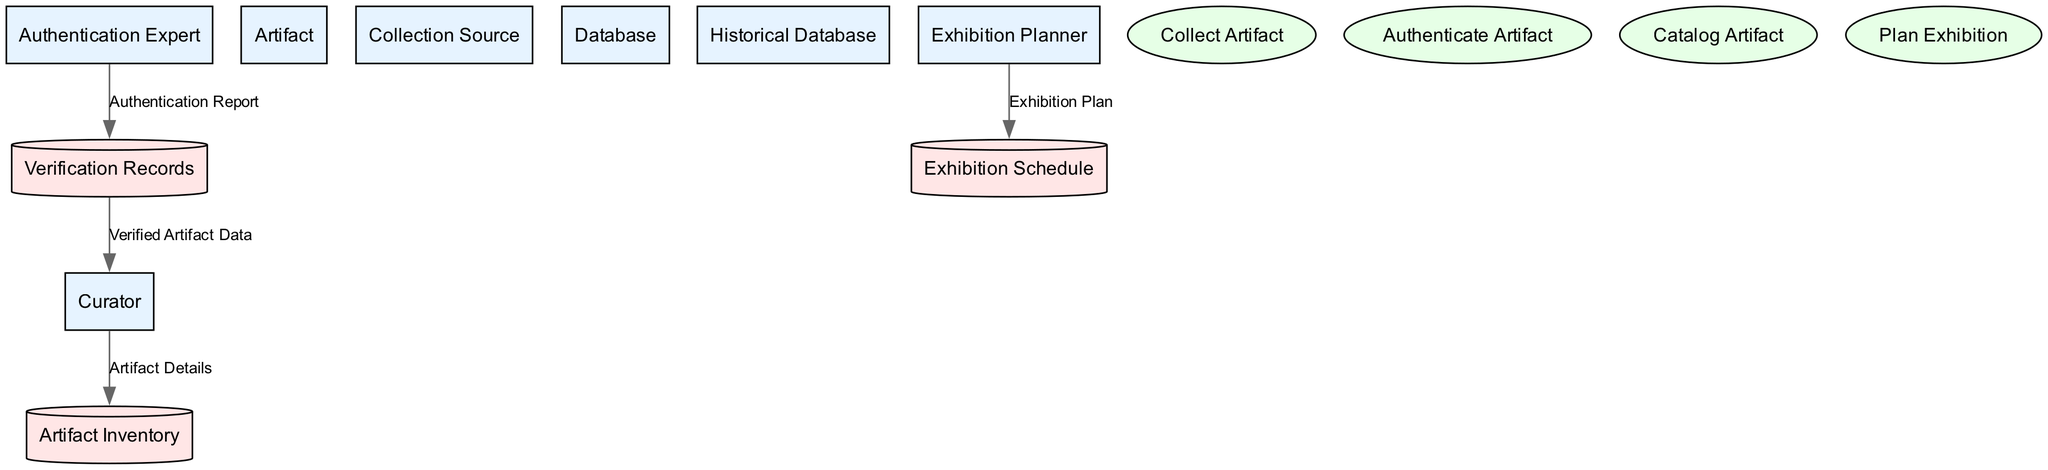What is the main role of the Curator in the diagram? The Curator is responsible for collecting, verifying, and cataloging artifacts and serves as a source for artifact details which flow into the Artifact Inventory.
Answer: Collecting, verifying, and cataloging artifacts How many data stores are present in the diagram? There are three data stores, which are the Artifact Inventory, Verification Records, and Exhibition Schedule.
Answer: Three What is the flow from the Authentication Expert to the Verification Records? The flow labeled "Authentication Report" indicates that findings and authenticity verifications of artifacts go from the Authentication Expert to the Verification Records.
Answer: Authentication Report What process comes before Cataloging Artifact? The process that comes before Cataloging Artifact is Collect Artifact, as artifacts must be collected before they can be cataloged.
Answer: Collect Artifact Which entity is responsible for planning exhibitions? The Exhibition Planner is responsible for planning exhibitions, as indicated in the data flows and processes related to the scheduling of exhibitions.
Answer: Exhibition Planner What is stored in the Verification Records? Verification Records maintain a log of authentication results and expert reviews regarding the collected artifacts.
Answer: Authentication results and expert reviews From which entity does the Exhibition Plan flow originate? The Exhibition Plan originates from the Exhibition Planner, who generates plans and schedules for upcoming exhibitions as indicated in the diagram.
Answer: Exhibition Planner Explain the relationship between the Verification Records and the Curator. The Verified Artifact Data flows from the Verification Records to the Curator, providing authentication statuses and details of verified artifacts, indicating a feedback loop where the Curator uses this information for further action on artifacts.
Answer: Verified Artifact Data What type of diagram is being described? The diagram being described is a Data Flow Diagram, which illustrates the flow of data between entities, processes, and data stores involved in the artifact collection process.
Answer: Data Flow Diagram 